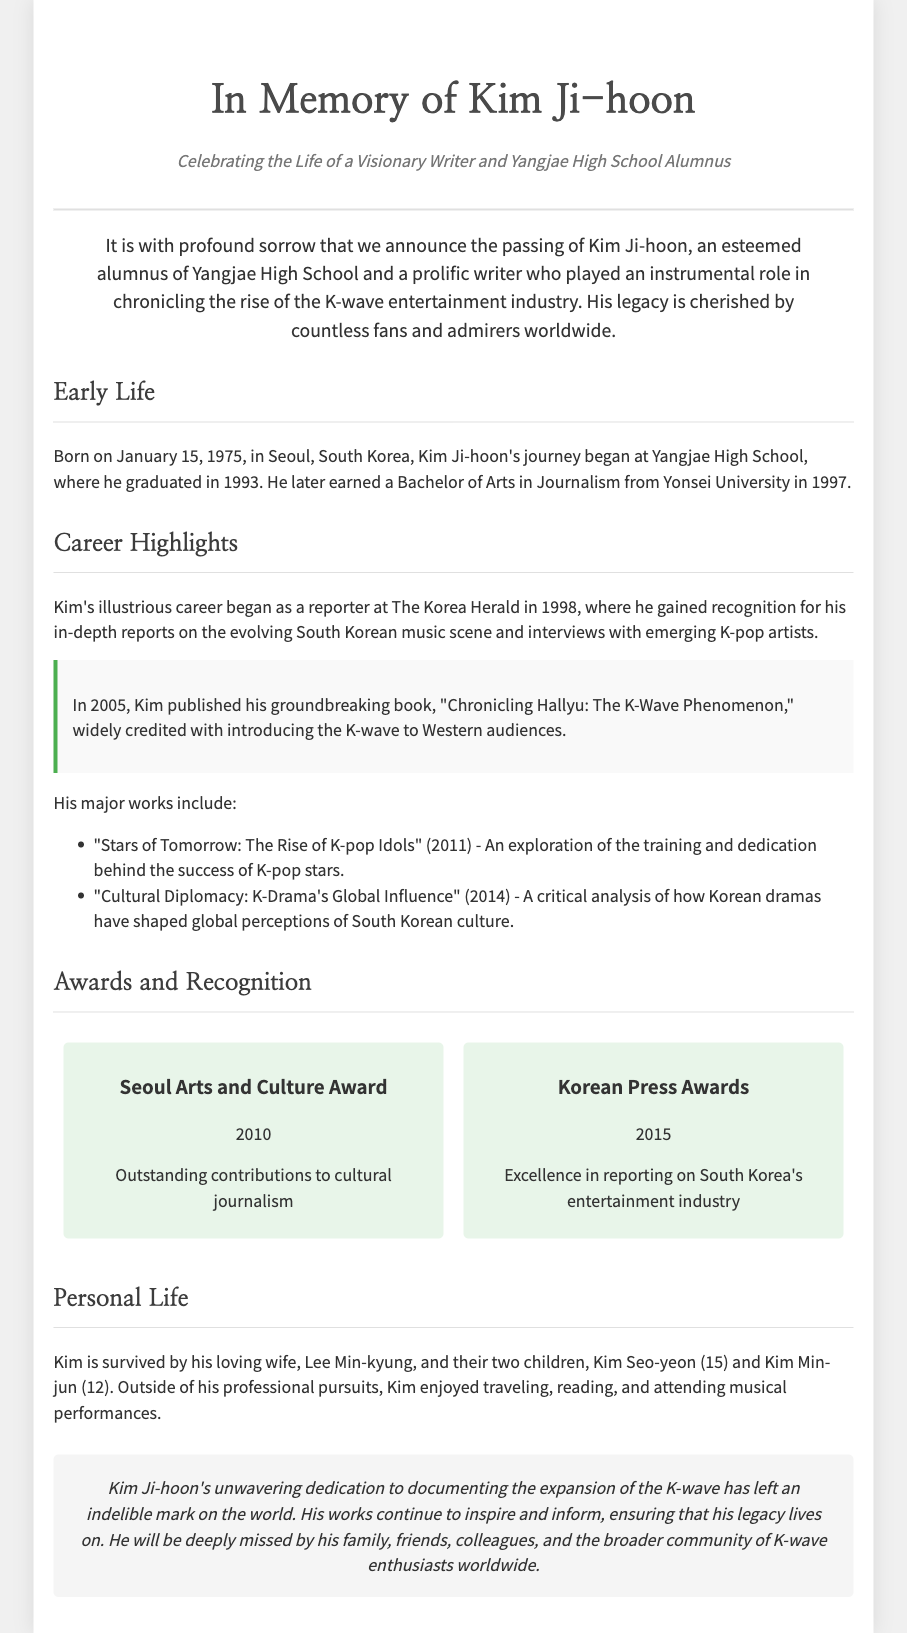What is the full name of the writer? The document states the full name of the writer as Kim Ji-hoon.
Answer: Kim Ji-hoon When was Kim Ji-hoon born? The document provides the birth date as January 15, 1975.
Answer: January 15, 1975 Which high school did he graduate from? The document mentions that he graduated from Yangjae High School.
Answer: Yangjae High School What was the title of Kim Ji-hoon's groundbreaking book? The document highlights the book titled "Chronicling Hallyu: The K-Wave Phenomenon."
Answer: Chronicling Hallyu: The K-Wave Phenomenon How many children did Kim Ji-hoon have? The document indicates that Kim Ji-hoon had two children.
Answer: Two children What major award did he win in 2010? The document states he won the Seoul Arts and Culture Award in 2010.
Answer: Seoul Arts and Culture Award What profession did Kim Ji-hoon pursue? The document specifies that he was a writer and journalist.
Answer: Writer and journalist Which university did he attend for his Bachelor's degree? The document mentions that he earned his degree from Yonsei University.
Answer: Yonsei University What year did he graduate from high school? The document indicates that he graduated in 1993.
Answer: 1993 